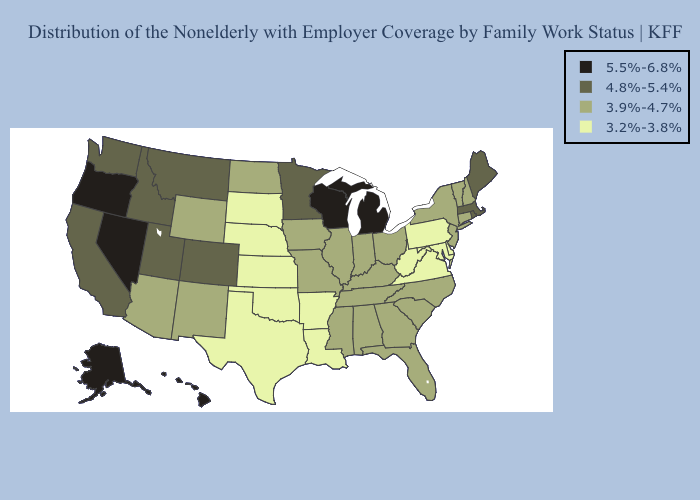What is the highest value in states that border Iowa?
Short answer required. 5.5%-6.8%. What is the highest value in states that border Georgia?
Give a very brief answer. 3.9%-4.7%. Does the map have missing data?
Give a very brief answer. No. What is the value of North Dakota?
Be succinct. 3.9%-4.7%. Which states have the lowest value in the West?
Concise answer only. Arizona, New Mexico, Wyoming. What is the value of South Carolina?
Short answer required. 3.9%-4.7%. Does the first symbol in the legend represent the smallest category?
Keep it brief. No. What is the highest value in states that border Virginia?
Answer briefly. 3.9%-4.7%. Does the first symbol in the legend represent the smallest category?
Write a very short answer. No. Name the states that have a value in the range 4.8%-5.4%?
Give a very brief answer. California, Colorado, Idaho, Maine, Massachusetts, Minnesota, Montana, Rhode Island, Utah, Washington. Does Delaware have the highest value in the South?
Short answer required. No. Does Missouri have a lower value than Nevada?
Keep it brief. Yes. What is the highest value in states that border New York?
Give a very brief answer. 4.8%-5.4%. What is the value of New Mexico?
Short answer required. 3.9%-4.7%. 